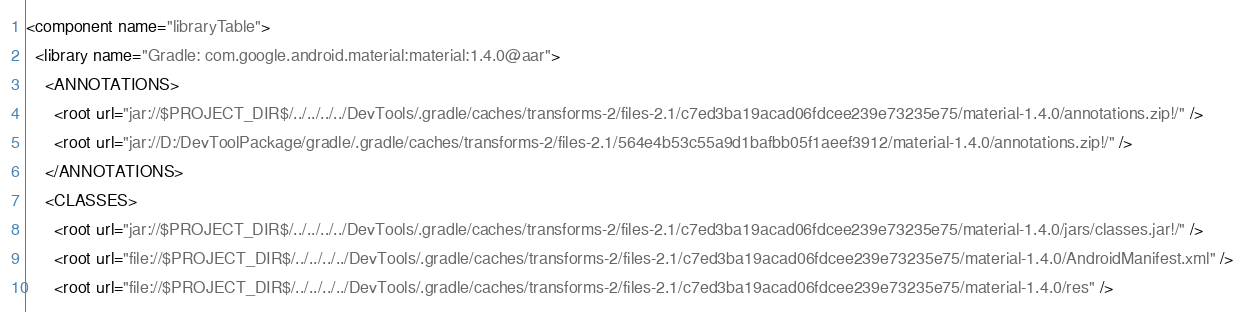Convert code to text. <code><loc_0><loc_0><loc_500><loc_500><_XML_><component name="libraryTable">
  <library name="Gradle: com.google.android.material:material:1.4.0@aar">
    <ANNOTATIONS>
      <root url="jar://$PROJECT_DIR$/../../../../DevTools/.gradle/caches/transforms-2/files-2.1/c7ed3ba19acad06fdcee239e73235e75/material-1.4.0/annotations.zip!/" />
      <root url="jar://D:/DevToolPackage/gradle/.gradle/caches/transforms-2/files-2.1/564e4b53c55a9d1bafbb05f1aeef3912/material-1.4.0/annotations.zip!/" />
    </ANNOTATIONS>
    <CLASSES>
      <root url="jar://$PROJECT_DIR$/../../../../DevTools/.gradle/caches/transforms-2/files-2.1/c7ed3ba19acad06fdcee239e73235e75/material-1.4.0/jars/classes.jar!/" />
      <root url="file://$PROJECT_DIR$/../../../../DevTools/.gradle/caches/transforms-2/files-2.1/c7ed3ba19acad06fdcee239e73235e75/material-1.4.0/AndroidManifest.xml" />
      <root url="file://$PROJECT_DIR$/../../../../DevTools/.gradle/caches/transforms-2/files-2.1/c7ed3ba19acad06fdcee239e73235e75/material-1.4.0/res" /></code> 